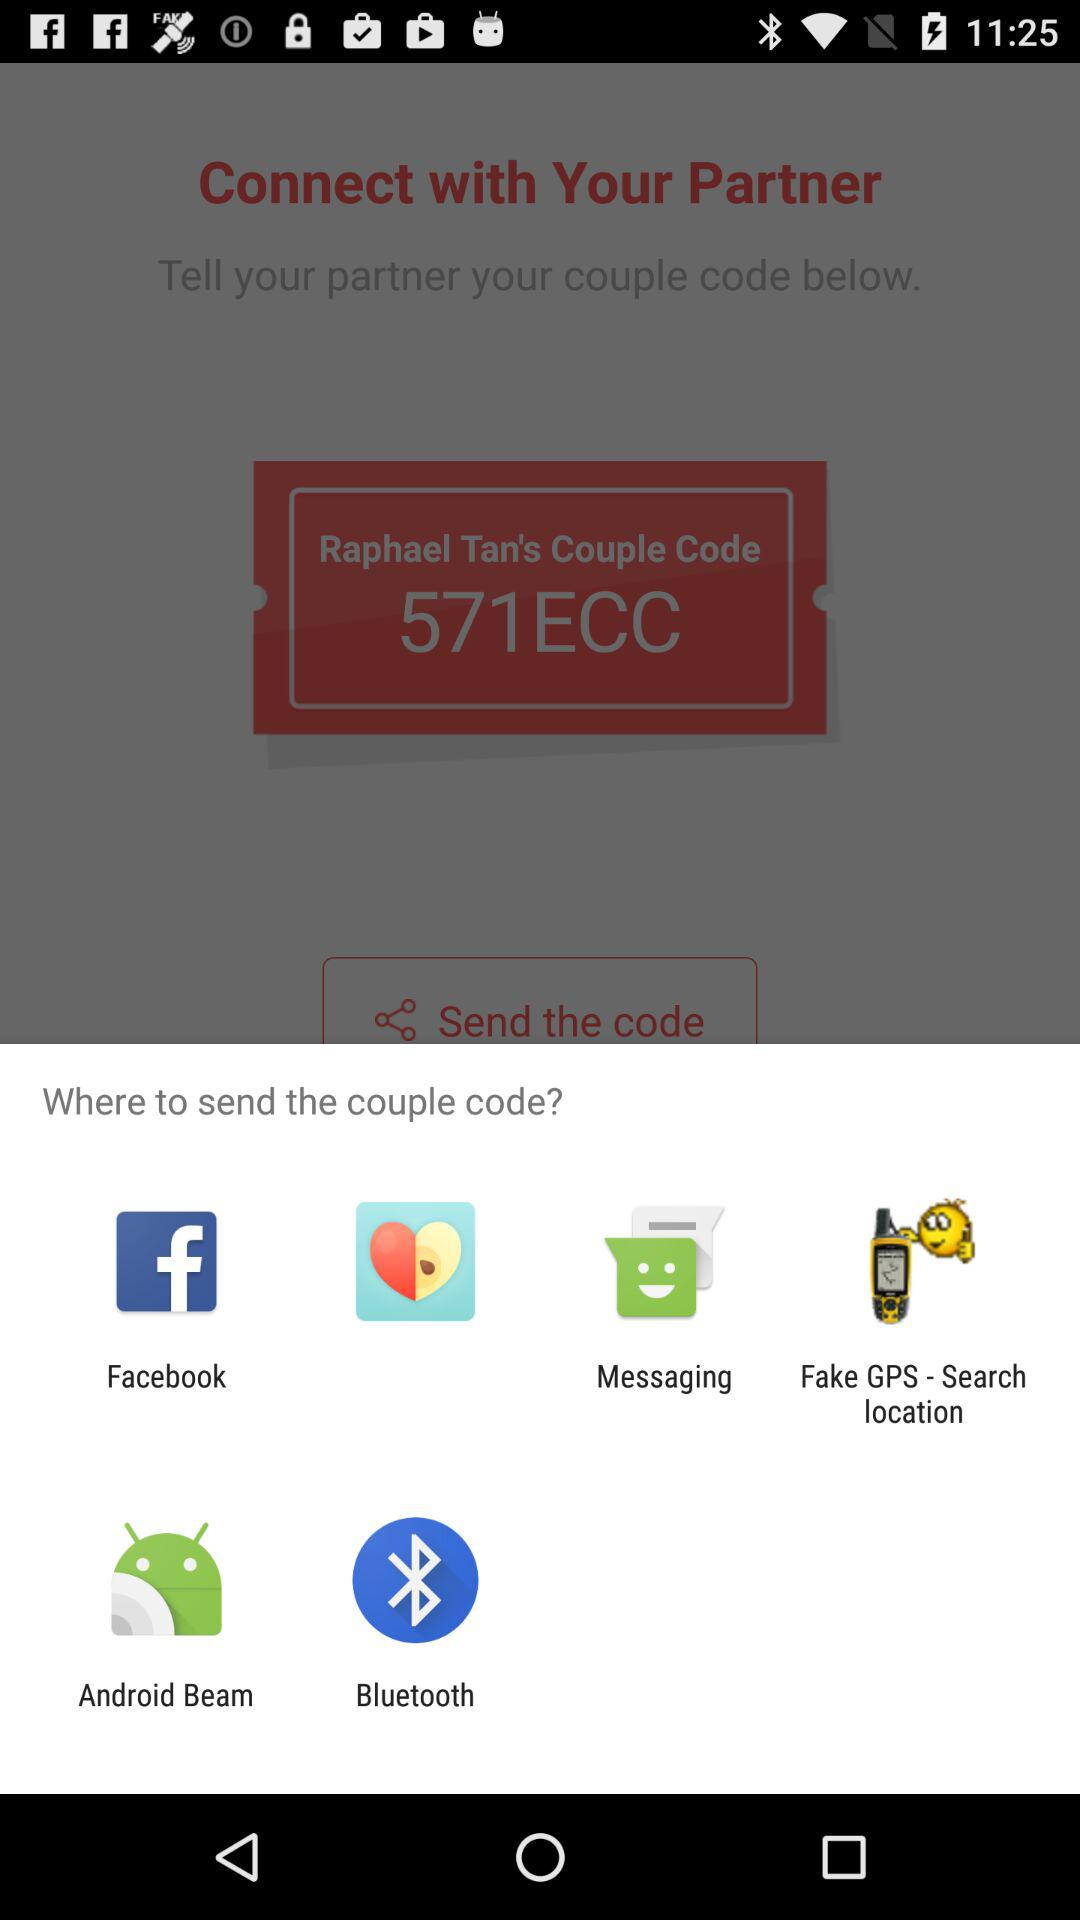Which applications can be used to send the couple code? The applications are "Facebook", "Couplete", "Messaging", "Fake GPS - Search location", "Android Beam" and "Bluetooth". 